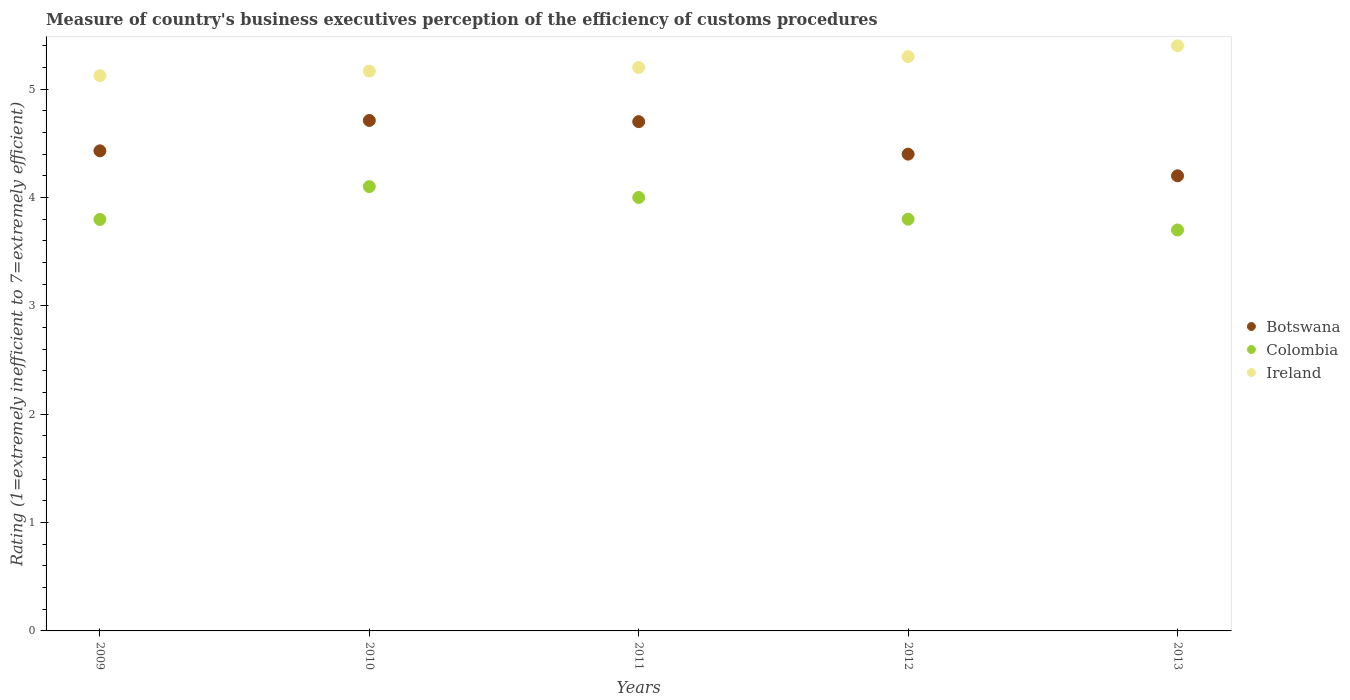How many different coloured dotlines are there?
Offer a very short reply. 3. Across all years, what is the maximum rating of the efficiency of customs procedure in Botswana?
Offer a very short reply. 4.71. Across all years, what is the minimum rating of the efficiency of customs procedure in Colombia?
Offer a very short reply. 3.7. In which year was the rating of the efficiency of customs procedure in Botswana minimum?
Offer a terse response. 2013. What is the total rating of the efficiency of customs procedure in Botswana in the graph?
Offer a very short reply. 22.44. What is the difference between the rating of the efficiency of customs procedure in Colombia in 2011 and that in 2012?
Provide a short and direct response. 0.2. What is the difference between the rating of the efficiency of customs procedure in Botswana in 2013 and the rating of the efficiency of customs procedure in Ireland in 2012?
Provide a short and direct response. -1.1. What is the average rating of the efficiency of customs procedure in Colombia per year?
Your answer should be very brief. 3.88. In the year 2009, what is the difference between the rating of the efficiency of customs procedure in Ireland and rating of the efficiency of customs procedure in Botswana?
Offer a terse response. 0.69. In how many years, is the rating of the efficiency of customs procedure in Ireland greater than 5.2?
Provide a succinct answer. 2. What is the ratio of the rating of the efficiency of customs procedure in Colombia in 2009 to that in 2012?
Your answer should be very brief. 1. Is the rating of the efficiency of customs procedure in Colombia in 2009 less than that in 2012?
Offer a terse response. Yes. What is the difference between the highest and the second highest rating of the efficiency of customs procedure in Colombia?
Keep it short and to the point. 0.1. What is the difference between the highest and the lowest rating of the efficiency of customs procedure in Colombia?
Give a very brief answer. 0.4. Is the sum of the rating of the efficiency of customs procedure in Botswana in 2010 and 2013 greater than the maximum rating of the efficiency of customs procedure in Colombia across all years?
Your answer should be compact. Yes. Is it the case that in every year, the sum of the rating of the efficiency of customs procedure in Colombia and rating of the efficiency of customs procedure in Ireland  is greater than the rating of the efficiency of customs procedure in Botswana?
Your answer should be very brief. Yes. Does the rating of the efficiency of customs procedure in Ireland monotonically increase over the years?
Give a very brief answer. Yes. Is the rating of the efficiency of customs procedure in Ireland strictly less than the rating of the efficiency of customs procedure in Botswana over the years?
Keep it short and to the point. No. Does the graph contain any zero values?
Give a very brief answer. No. Where does the legend appear in the graph?
Your answer should be very brief. Center right. How many legend labels are there?
Offer a very short reply. 3. What is the title of the graph?
Offer a terse response. Measure of country's business executives perception of the efficiency of customs procedures. Does "Cayman Islands" appear as one of the legend labels in the graph?
Provide a succinct answer. No. What is the label or title of the X-axis?
Your answer should be very brief. Years. What is the label or title of the Y-axis?
Your response must be concise. Rating (1=extremely inefficient to 7=extremely efficient). What is the Rating (1=extremely inefficient to 7=extremely efficient) in Botswana in 2009?
Your answer should be very brief. 4.43. What is the Rating (1=extremely inefficient to 7=extremely efficient) in Colombia in 2009?
Offer a terse response. 3.8. What is the Rating (1=extremely inefficient to 7=extremely efficient) in Ireland in 2009?
Provide a short and direct response. 5.12. What is the Rating (1=extremely inefficient to 7=extremely efficient) of Botswana in 2010?
Make the answer very short. 4.71. What is the Rating (1=extremely inefficient to 7=extremely efficient) of Colombia in 2010?
Your answer should be compact. 4.1. What is the Rating (1=extremely inefficient to 7=extremely efficient) of Ireland in 2010?
Ensure brevity in your answer.  5.17. What is the Rating (1=extremely inefficient to 7=extremely efficient) in Botswana in 2012?
Give a very brief answer. 4.4. What is the Rating (1=extremely inefficient to 7=extremely efficient) in Ireland in 2012?
Make the answer very short. 5.3. Across all years, what is the maximum Rating (1=extremely inefficient to 7=extremely efficient) in Botswana?
Provide a succinct answer. 4.71. Across all years, what is the maximum Rating (1=extremely inefficient to 7=extremely efficient) in Colombia?
Provide a short and direct response. 4.1. Across all years, what is the minimum Rating (1=extremely inefficient to 7=extremely efficient) in Colombia?
Give a very brief answer. 3.7. Across all years, what is the minimum Rating (1=extremely inefficient to 7=extremely efficient) in Ireland?
Ensure brevity in your answer.  5.12. What is the total Rating (1=extremely inefficient to 7=extremely efficient) in Botswana in the graph?
Your answer should be very brief. 22.44. What is the total Rating (1=extremely inefficient to 7=extremely efficient) in Colombia in the graph?
Provide a short and direct response. 19.4. What is the total Rating (1=extremely inefficient to 7=extremely efficient) in Ireland in the graph?
Provide a succinct answer. 26.19. What is the difference between the Rating (1=extremely inefficient to 7=extremely efficient) in Botswana in 2009 and that in 2010?
Keep it short and to the point. -0.28. What is the difference between the Rating (1=extremely inefficient to 7=extremely efficient) in Colombia in 2009 and that in 2010?
Give a very brief answer. -0.3. What is the difference between the Rating (1=extremely inefficient to 7=extremely efficient) of Ireland in 2009 and that in 2010?
Make the answer very short. -0.04. What is the difference between the Rating (1=extremely inefficient to 7=extremely efficient) in Botswana in 2009 and that in 2011?
Your response must be concise. -0.27. What is the difference between the Rating (1=extremely inefficient to 7=extremely efficient) in Colombia in 2009 and that in 2011?
Give a very brief answer. -0.2. What is the difference between the Rating (1=extremely inefficient to 7=extremely efficient) in Ireland in 2009 and that in 2011?
Your answer should be compact. -0.08. What is the difference between the Rating (1=extremely inefficient to 7=extremely efficient) of Botswana in 2009 and that in 2012?
Provide a succinct answer. 0.03. What is the difference between the Rating (1=extremely inefficient to 7=extremely efficient) of Colombia in 2009 and that in 2012?
Make the answer very short. -0. What is the difference between the Rating (1=extremely inefficient to 7=extremely efficient) in Ireland in 2009 and that in 2012?
Offer a terse response. -0.18. What is the difference between the Rating (1=extremely inefficient to 7=extremely efficient) in Botswana in 2009 and that in 2013?
Keep it short and to the point. 0.23. What is the difference between the Rating (1=extremely inefficient to 7=extremely efficient) of Colombia in 2009 and that in 2013?
Keep it short and to the point. 0.1. What is the difference between the Rating (1=extremely inefficient to 7=extremely efficient) of Ireland in 2009 and that in 2013?
Your answer should be very brief. -0.28. What is the difference between the Rating (1=extremely inefficient to 7=extremely efficient) of Botswana in 2010 and that in 2011?
Offer a very short reply. 0.01. What is the difference between the Rating (1=extremely inefficient to 7=extremely efficient) of Colombia in 2010 and that in 2011?
Your response must be concise. 0.1. What is the difference between the Rating (1=extremely inefficient to 7=extremely efficient) of Ireland in 2010 and that in 2011?
Provide a short and direct response. -0.03. What is the difference between the Rating (1=extremely inefficient to 7=extremely efficient) in Botswana in 2010 and that in 2012?
Make the answer very short. 0.31. What is the difference between the Rating (1=extremely inefficient to 7=extremely efficient) in Colombia in 2010 and that in 2012?
Your answer should be compact. 0.3. What is the difference between the Rating (1=extremely inefficient to 7=extremely efficient) of Ireland in 2010 and that in 2012?
Make the answer very short. -0.13. What is the difference between the Rating (1=extremely inefficient to 7=extremely efficient) in Botswana in 2010 and that in 2013?
Provide a short and direct response. 0.51. What is the difference between the Rating (1=extremely inefficient to 7=extremely efficient) of Colombia in 2010 and that in 2013?
Your response must be concise. 0.4. What is the difference between the Rating (1=extremely inefficient to 7=extremely efficient) of Ireland in 2010 and that in 2013?
Keep it short and to the point. -0.23. What is the difference between the Rating (1=extremely inefficient to 7=extremely efficient) in Botswana in 2011 and that in 2012?
Your answer should be compact. 0.3. What is the difference between the Rating (1=extremely inefficient to 7=extremely efficient) of Ireland in 2011 and that in 2012?
Offer a terse response. -0.1. What is the difference between the Rating (1=extremely inefficient to 7=extremely efficient) of Botswana in 2011 and that in 2013?
Ensure brevity in your answer.  0.5. What is the difference between the Rating (1=extremely inefficient to 7=extremely efficient) of Colombia in 2011 and that in 2013?
Keep it short and to the point. 0.3. What is the difference between the Rating (1=extremely inefficient to 7=extremely efficient) of Ireland in 2011 and that in 2013?
Offer a very short reply. -0.2. What is the difference between the Rating (1=extremely inefficient to 7=extremely efficient) in Botswana in 2012 and that in 2013?
Your answer should be very brief. 0.2. What is the difference between the Rating (1=extremely inefficient to 7=extremely efficient) of Ireland in 2012 and that in 2013?
Keep it short and to the point. -0.1. What is the difference between the Rating (1=extremely inefficient to 7=extremely efficient) of Botswana in 2009 and the Rating (1=extremely inefficient to 7=extremely efficient) of Colombia in 2010?
Make the answer very short. 0.33. What is the difference between the Rating (1=extremely inefficient to 7=extremely efficient) of Botswana in 2009 and the Rating (1=extremely inefficient to 7=extremely efficient) of Ireland in 2010?
Offer a terse response. -0.74. What is the difference between the Rating (1=extremely inefficient to 7=extremely efficient) of Colombia in 2009 and the Rating (1=extremely inefficient to 7=extremely efficient) of Ireland in 2010?
Offer a terse response. -1.37. What is the difference between the Rating (1=extremely inefficient to 7=extremely efficient) of Botswana in 2009 and the Rating (1=extremely inefficient to 7=extremely efficient) of Colombia in 2011?
Your answer should be very brief. 0.43. What is the difference between the Rating (1=extremely inefficient to 7=extremely efficient) in Botswana in 2009 and the Rating (1=extremely inefficient to 7=extremely efficient) in Ireland in 2011?
Keep it short and to the point. -0.77. What is the difference between the Rating (1=extremely inefficient to 7=extremely efficient) in Colombia in 2009 and the Rating (1=extremely inefficient to 7=extremely efficient) in Ireland in 2011?
Your answer should be very brief. -1.4. What is the difference between the Rating (1=extremely inefficient to 7=extremely efficient) in Botswana in 2009 and the Rating (1=extremely inefficient to 7=extremely efficient) in Colombia in 2012?
Your response must be concise. 0.63. What is the difference between the Rating (1=extremely inefficient to 7=extremely efficient) of Botswana in 2009 and the Rating (1=extremely inefficient to 7=extremely efficient) of Ireland in 2012?
Your answer should be compact. -0.87. What is the difference between the Rating (1=extremely inefficient to 7=extremely efficient) of Colombia in 2009 and the Rating (1=extremely inefficient to 7=extremely efficient) of Ireland in 2012?
Your answer should be compact. -1.5. What is the difference between the Rating (1=extremely inefficient to 7=extremely efficient) of Botswana in 2009 and the Rating (1=extremely inefficient to 7=extremely efficient) of Colombia in 2013?
Keep it short and to the point. 0.73. What is the difference between the Rating (1=extremely inefficient to 7=extremely efficient) in Botswana in 2009 and the Rating (1=extremely inefficient to 7=extremely efficient) in Ireland in 2013?
Provide a short and direct response. -0.97. What is the difference between the Rating (1=extremely inefficient to 7=extremely efficient) in Colombia in 2009 and the Rating (1=extremely inefficient to 7=extremely efficient) in Ireland in 2013?
Your answer should be very brief. -1.6. What is the difference between the Rating (1=extremely inefficient to 7=extremely efficient) of Botswana in 2010 and the Rating (1=extremely inefficient to 7=extremely efficient) of Colombia in 2011?
Your answer should be very brief. 0.71. What is the difference between the Rating (1=extremely inefficient to 7=extremely efficient) in Botswana in 2010 and the Rating (1=extremely inefficient to 7=extremely efficient) in Ireland in 2011?
Give a very brief answer. -0.49. What is the difference between the Rating (1=extremely inefficient to 7=extremely efficient) of Colombia in 2010 and the Rating (1=extremely inefficient to 7=extremely efficient) of Ireland in 2011?
Provide a short and direct response. -1.1. What is the difference between the Rating (1=extremely inefficient to 7=extremely efficient) in Botswana in 2010 and the Rating (1=extremely inefficient to 7=extremely efficient) in Colombia in 2012?
Provide a succinct answer. 0.91. What is the difference between the Rating (1=extremely inefficient to 7=extremely efficient) of Botswana in 2010 and the Rating (1=extremely inefficient to 7=extremely efficient) of Ireland in 2012?
Provide a short and direct response. -0.59. What is the difference between the Rating (1=extremely inefficient to 7=extremely efficient) of Colombia in 2010 and the Rating (1=extremely inefficient to 7=extremely efficient) of Ireland in 2012?
Your response must be concise. -1.2. What is the difference between the Rating (1=extremely inefficient to 7=extremely efficient) of Botswana in 2010 and the Rating (1=extremely inefficient to 7=extremely efficient) of Colombia in 2013?
Make the answer very short. 1.01. What is the difference between the Rating (1=extremely inefficient to 7=extremely efficient) of Botswana in 2010 and the Rating (1=extremely inefficient to 7=extremely efficient) of Ireland in 2013?
Provide a short and direct response. -0.69. What is the difference between the Rating (1=extremely inefficient to 7=extremely efficient) of Colombia in 2010 and the Rating (1=extremely inefficient to 7=extremely efficient) of Ireland in 2013?
Your answer should be compact. -1.3. What is the difference between the Rating (1=extremely inefficient to 7=extremely efficient) of Botswana in 2011 and the Rating (1=extremely inefficient to 7=extremely efficient) of Colombia in 2012?
Your answer should be compact. 0.9. What is the difference between the Rating (1=extremely inefficient to 7=extremely efficient) of Colombia in 2011 and the Rating (1=extremely inefficient to 7=extremely efficient) of Ireland in 2012?
Your answer should be very brief. -1.3. What is the difference between the Rating (1=extremely inefficient to 7=extremely efficient) in Botswana in 2011 and the Rating (1=extremely inefficient to 7=extremely efficient) in Ireland in 2013?
Make the answer very short. -0.7. What is the difference between the Rating (1=extremely inefficient to 7=extremely efficient) in Botswana in 2012 and the Rating (1=extremely inefficient to 7=extremely efficient) in Ireland in 2013?
Keep it short and to the point. -1. What is the difference between the Rating (1=extremely inefficient to 7=extremely efficient) in Colombia in 2012 and the Rating (1=extremely inefficient to 7=extremely efficient) in Ireland in 2013?
Your answer should be very brief. -1.6. What is the average Rating (1=extremely inefficient to 7=extremely efficient) in Botswana per year?
Ensure brevity in your answer.  4.49. What is the average Rating (1=extremely inefficient to 7=extremely efficient) in Colombia per year?
Your response must be concise. 3.88. What is the average Rating (1=extremely inefficient to 7=extremely efficient) of Ireland per year?
Your response must be concise. 5.24. In the year 2009, what is the difference between the Rating (1=extremely inefficient to 7=extremely efficient) of Botswana and Rating (1=extremely inefficient to 7=extremely efficient) of Colombia?
Make the answer very short. 0.63. In the year 2009, what is the difference between the Rating (1=extremely inefficient to 7=extremely efficient) in Botswana and Rating (1=extremely inefficient to 7=extremely efficient) in Ireland?
Your answer should be very brief. -0.69. In the year 2009, what is the difference between the Rating (1=extremely inefficient to 7=extremely efficient) in Colombia and Rating (1=extremely inefficient to 7=extremely efficient) in Ireland?
Your answer should be very brief. -1.33. In the year 2010, what is the difference between the Rating (1=extremely inefficient to 7=extremely efficient) of Botswana and Rating (1=extremely inefficient to 7=extremely efficient) of Colombia?
Give a very brief answer. 0.61. In the year 2010, what is the difference between the Rating (1=extremely inefficient to 7=extremely efficient) in Botswana and Rating (1=extremely inefficient to 7=extremely efficient) in Ireland?
Your answer should be very brief. -0.46. In the year 2010, what is the difference between the Rating (1=extremely inefficient to 7=extremely efficient) of Colombia and Rating (1=extremely inefficient to 7=extremely efficient) of Ireland?
Offer a terse response. -1.07. In the year 2011, what is the difference between the Rating (1=extremely inefficient to 7=extremely efficient) of Botswana and Rating (1=extremely inefficient to 7=extremely efficient) of Ireland?
Provide a succinct answer. -0.5. In the year 2012, what is the difference between the Rating (1=extremely inefficient to 7=extremely efficient) in Botswana and Rating (1=extremely inefficient to 7=extremely efficient) in Ireland?
Make the answer very short. -0.9. In the year 2012, what is the difference between the Rating (1=extremely inefficient to 7=extremely efficient) of Colombia and Rating (1=extremely inefficient to 7=extremely efficient) of Ireland?
Give a very brief answer. -1.5. What is the ratio of the Rating (1=extremely inefficient to 7=extremely efficient) in Botswana in 2009 to that in 2010?
Your answer should be very brief. 0.94. What is the ratio of the Rating (1=extremely inefficient to 7=extremely efficient) of Colombia in 2009 to that in 2010?
Keep it short and to the point. 0.93. What is the ratio of the Rating (1=extremely inefficient to 7=extremely efficient) of Ireland in 2009 to that in 2010?
Your answer should be compact. 0.99. What is the ratio of the Rating (1=extremely inefficient to 7=extremely efficient) of Botswana in 2009 to that in 2011?
Ensure brevity in your answer.  0.94. What is the ratio of the Rating (1=extremely inefficient to 7=extremely efficient) in Colombia in 2009 to that in 2011?
Offer a very short reply. 0.95. What is the ratio of the Rating (1=extremely inefficient to 7=extremely efficient) in Ireland in 2009 to that in 2011?
Offer a terse response. 0.99. What is the ratio of the Rating (1=extremely inefficient to 7=extremely efficient) of Botswana in 2009 to that in 2012?
Keep it short and to the point. 1.01. What is the ratio of the Rating (1=extremely inefficient to 7=extremely efficient) in Ireland in 2009 to that in 2012?
Provide a short and direct response. 0.97. What is the ratio of the Rating (1=extremely inefficient to 7=extremely efficient) of Botswana in 2009 to that in 2013?
Offer a very short reply. 1.05. What is the ratio of the Rating (1=extremely inefficient to 7=extremely efficient) of Colombia in 2009 to that in 2013?
Offer a terse response. 1.03. What is the ratio of the Rating (1=extremely inefficient to 7=extremely efficient) of Ireland in 2009 to that in 2013?
Offer a terse response. 0.95. What is the ratio of the Rating (1=extremely inefficient to 7=extremely efficient) in Colombia in 2010 to that in 2011?
Provide a succinct answer. 1.03. What is the ratio of the Rating (1=extremely inefficient to 7=extremely efficient) in Ireland in 2010 to that in 2011?
Provide a short and direct response. 0.99. What is the ratio of the Rating (1=extremely inefficient to 7=extremely efficient) of Botswana in 2010 to that in 2012?
Give a very brief answer. 1.07. What is the ratio of the Rating (1=extremely inefficient to 7=extremely efficient) in Colombia in 2010 to that in 2012?
Keep it short and to the point. 1.08. What is the ratio of the Rating (1=extremely inefficient to 7=extremely efficient) in Ireland in 2010 to that in 2012?
Your answer should be very brief. 0.97. What is the ratio of the Rating (1=extremely inefficient to 7=extremely efficient) in Botswana in 2010 to that in 2013?
Keep it short and to the point. 1.12. What is the ratio of the Rating (1=extremely inefficient to 7=extremely efficient) of Colombia in 2010 to that in 2013?
Your answer should be compact. 1.11. What is the ratio of the Rating (1=extremely inefficient to 7=extremely efficient) in Ireland in 2010 to that in 2013?
Offer a very short reply. 0.96. What is the ratio of the Rating (1=extremely inefficient to 7=extremely efficient) in Botswana in 2011 to that in 2012?
Your answer should be compact. 1.07. What is the ratio of the Rating (1=extremely inefficient to 7=extremely efficient) in Colombia in 2011 to that in 2012?
Your answer should be compact. 1.05. What is the ratio of the Rating (1=extremely inefficient to 7=extremely efficient) of Ireland in 2011 to that in 2012?
Offer a terse response. 0.98. What is the ratio of the Rating (1=extremely inefficient to 7=extremely efficient) of Botswana in 2011 to that in 2013?
Keep it short and to the point. 1.12. What is the ratio of the Rating (1=extremely inefficient to 7=extremely efficient) of Colombia in 2011 to that in 2013?
Offer a very short reply. 1.08. What is the ratio of the Rating (1=extremely inefficient to 7=extremely efficient) in Ireland in 2011 to that in 2013?
Offer a very short reply. 0.96. What is the ratio of the Rating (1=extremely inefficient to 7=extremely efficient) in Botswana in 2012 to that in 2013?
Make the answer very short. 1.05. What is the ratio of the Rating (1=extremely inefficient to 7=extremely efficient) in Colombia in 2012 to that in 2013?
Provide a succinct answer. 1.03. What is the ratio of the Rating (1=extremely inefficient to 7=extremely efficient) in Ireland in 2012 to that in 2013?
Your answer should be compact. 0.98. What is the difference between the highest and the second highest Rating (1=extremely inefficient to 7=extremely efficient) in Botswana?
Provide a short and direct response. 0.01. What is the difference between the highest and the second highest Rating (1=extremely inefficient to 7=extremely efficient) in Colombia?
Provide a succinct answer. 0.1. What is the difference between the highest and the second highest Rating (1=extremely inefficient to 7=extremely efficient) of Ireland?
Offer a very short reply. 0.1. What is the difference between the highest and the lowest Rating (1=extremely inefficient to 7=extremely efficient) of Botswana?
Your answer should be compact. 0.51. What is the difference between the highest and the lowest Rating (1=extremely inefficient to 7=extremely efficient) of Colombia?
Keep it short and to the point. 0.4. What is the difference between the highest and the lowest Rating (1=extremely inefficient to 7=extremely efficient) in Ireland?
Offer a terse response. 0.28. 